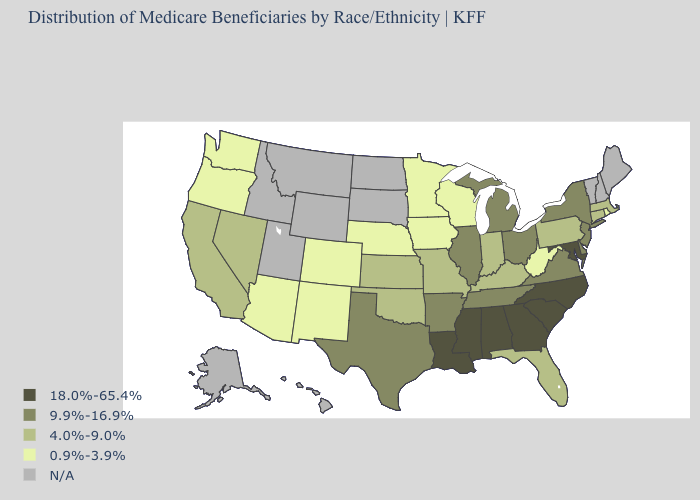What is the lowest value in states that border Washington?
Write a very short answer. 0.9%-3.9%. Name the states that have a value in the range N/A?
Short answer required. Alaska, Hawaii, Idaho, Maine, Montana, New Hampshire, North Dakota, South Dakota, Utah, Vermont, Wyoming. What is the value of Wyoming?
Quick response, please. N/A. Does the first symbol in the legend represent the smallest category?
Give a very brief answer. No. How many symbols are there in the legend?
Concise answer only. 5. Name the states that have a value in the range 18.0%-65.4%?
Answer briefly. Alabama, Georgia, Louisiana, Maryland, Mississippi, North Carolina, South Carolina. Does the map have missing data?
Be succinct. Yes. Does Iowa have the lowest value in the MidWest?
Write a very short answer. Yes. Among the states that border Mississippi , which have the highest value?
Answer briefly. Alabama, Louisiana. Among the states that border North Carolina , which have the highest value?
Give a very brief answer. Georgia, South Carolina. Name the states that have a value in the range 9.9%-16.9%?
Be succinct. Arkansas, Delaware, Illinois, Michigan, New Jersey, New York, Ohio, Tennessee, Texas, Virginia. What is the value of North Dakota?
Give a very brief answer. N/A. 